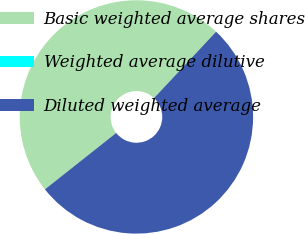Convert chart to OTSL. <chart><loc_0><loc_0><loc_500><loc_500><pie_chart><fcel>Basic weighted average shares<fcel>Weighted average dilutive<fcel>Diluted weighted average<nl><fcel>47.62%<fcel>0.0%<fcel>52.38%<nl></chart> 